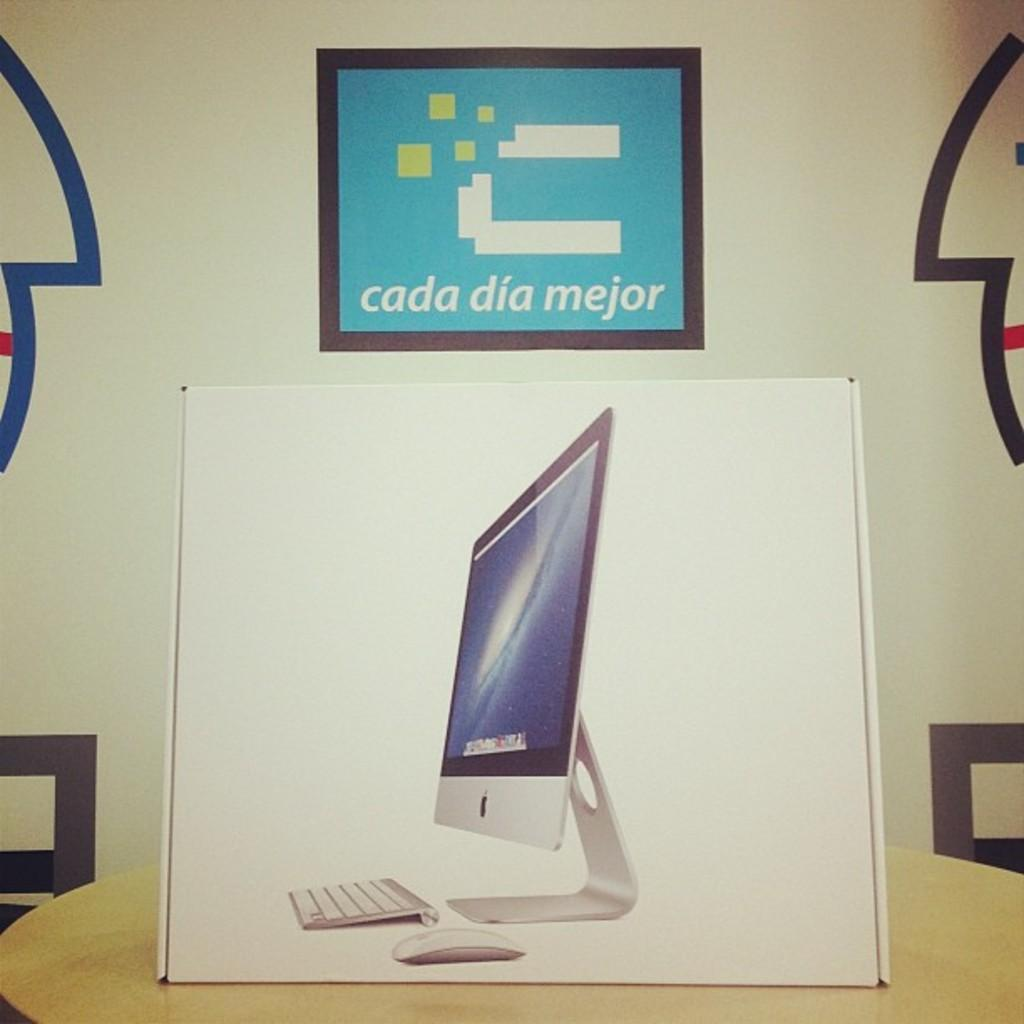<image>
Create a compact narrative representing the image presented. A computer box with a flyer above it that says cada dia mejor. 